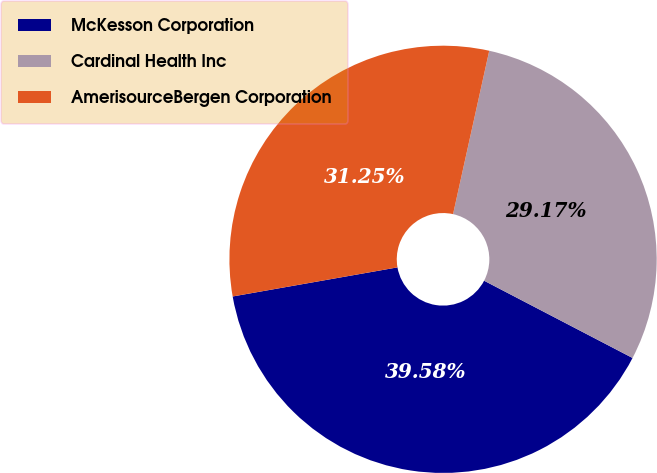<chart> <loc_0><loc_0><loc_500><loc_500><pie_chart><fcel>McKesson Corporation<fcel>Cardinal Health Inc<fcel>AmerisourceBergen Corporation<nl><fcel>39.58%<fcel>29.17%<fcel>31.25%<nl></chart> 